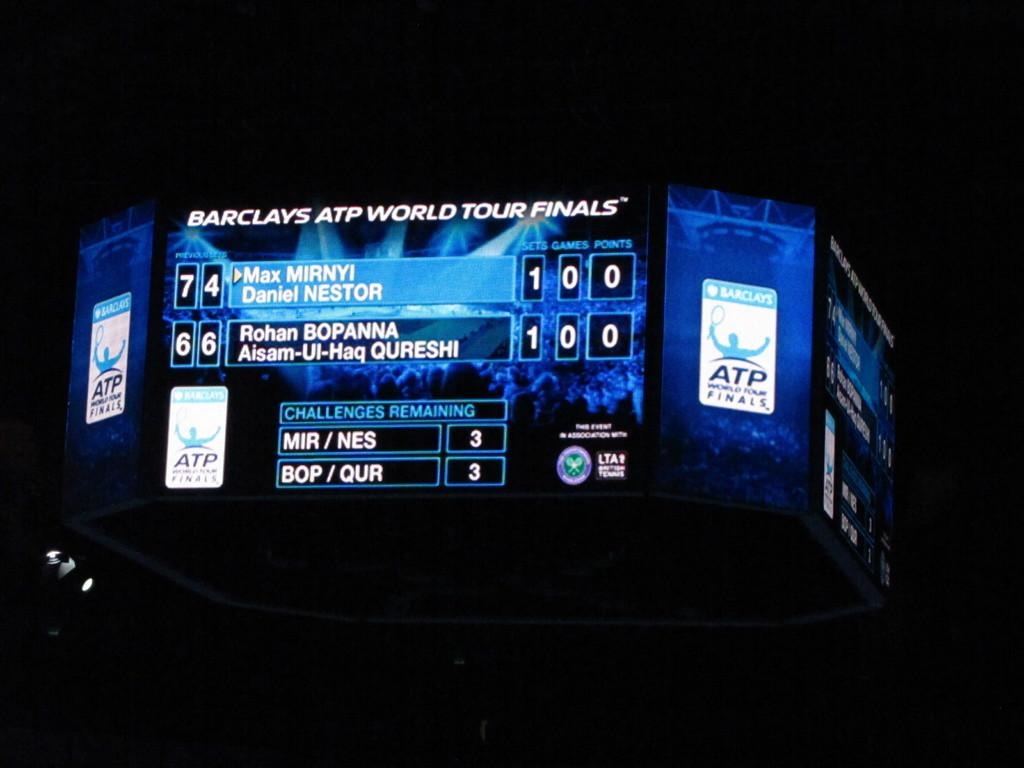<image>
Share a concise interpretation of the image provided. The Jumbo tron showing the score of the ATP world tour finals at the Barclays Center. 